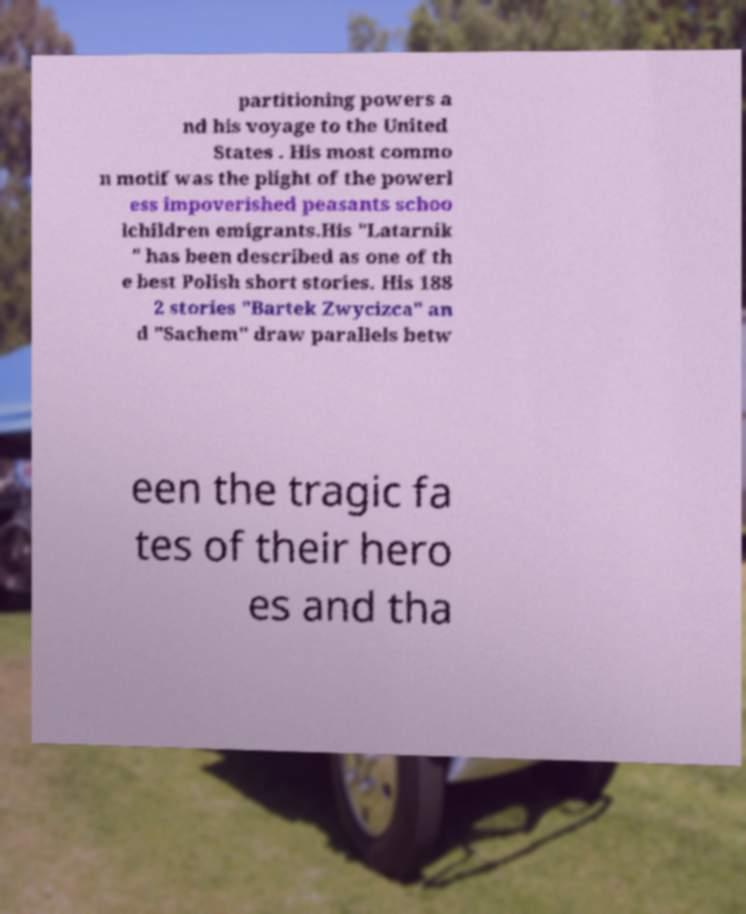Could you extract and type out the text from this image? partitioning powers a nd his voyage to the United States . His most commo n motif was the plight of the powerl ess impoverished peasants schoo lchildren emigrants.His "Latarnik " has been described as one of th e best Polish short stories. His 188 2 stories "Bartek Zwycizca" an d "Sachem" draw parallels betw een the tragic fa tes of their hero es and tha 